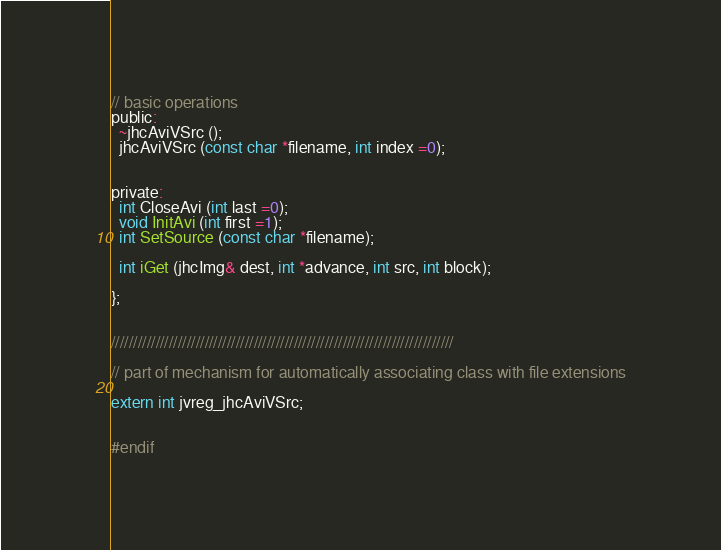Convert code to text. <code><loc_0><loc_0><loc_500><loc_500><_C_>
// basic operations
public:
  ~jhcAviVSrc ();
  jhcAviVSrc (const char *filename, int index =0);


private:
  int CloseAvi (int last =0);
  void InitAvi (int first =1);
  int SetSource (const char *filename);

  int iGet (jhcImg& dest, int *advance, int src, int block);

};


/////////////////////////////////////////////////////////////////////////////

// part of mechanism for automatically associating class with file extensions

extern int jvreg_jhcAviVSrc;


#endif
</code> 